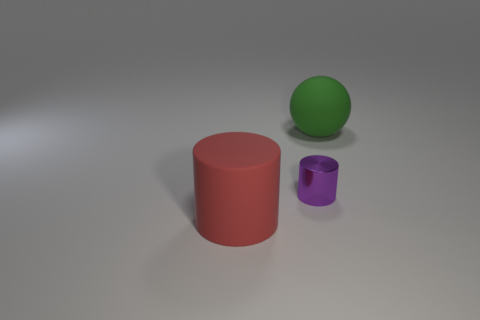Are there any other things that have the same material as the small object?
Keep it short and to the point. No. What number of things are either big rubber things that are right of the red object or yellow matte blocks?
Provide a short and direct response. 1. What color is the sphere that is made of the same material as the large red object?
Your answer should be compact. Green. Are there any shiny cylinders that have the same size as the green sphere?
Offer a terse response. No. Do the big object on the left side of the green thing and the sphere have the same color?
Provide a short and direct response. No. There is a object that is in front of the ball and behind the large red matte thing; what is its color?
Keep it short and to the point. Purple. The red matte object that is the same size as the green thing is what shape?
Make the answer very short. Cylinder. Is there a small green object that has the same shape as the big red matte thing?
Offer a very short reply. No. There is a cylinder behind the red matte cylinder; is it the same size as the green ball?
Your answer should be very brief. No. There is a thing that is both behind the red cylinder and left of the green matte object; what is its size?
Ensure brevity in your answer.  Small. 